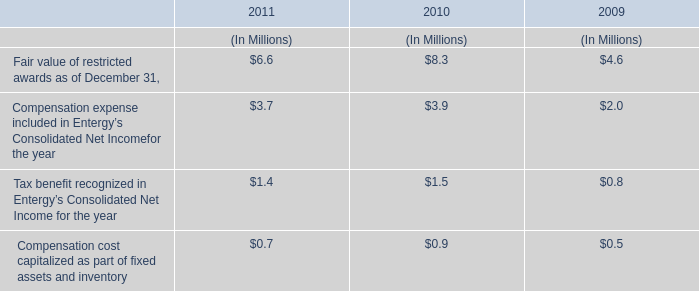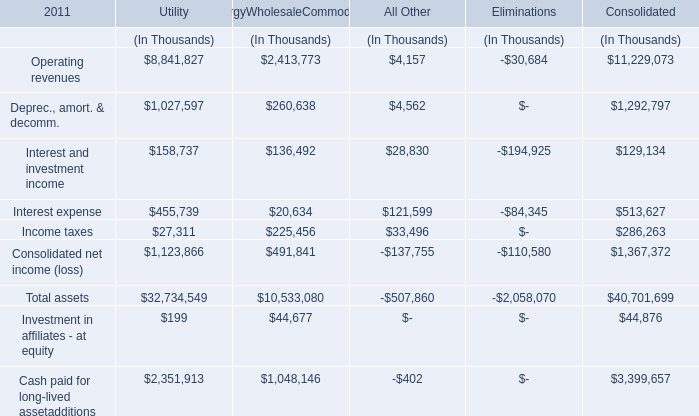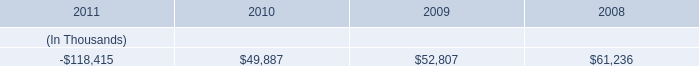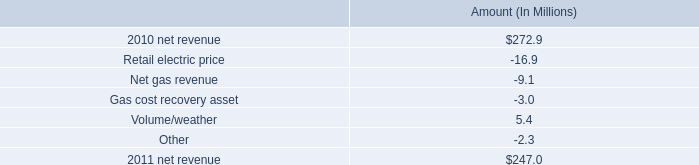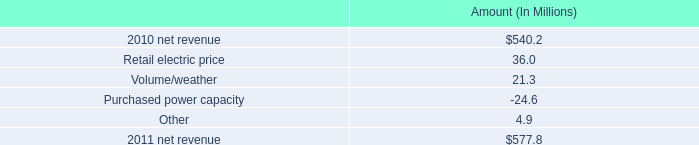Is the total amount of all elements in 2011 greater than that in 2010? 
Answer: no. 